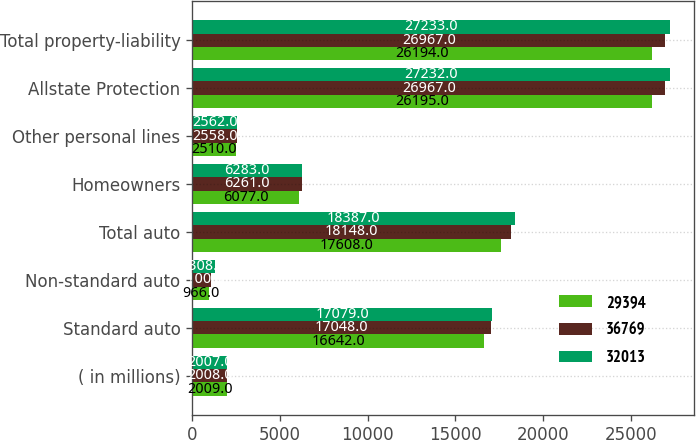Convert chart. <chart><loc_0><loc_0><loc_500><loc_500><stacked_bar_chart><ecel><fcel>( in millions)<fcel>Standard auto<fcel>Non-standard auto<fcel>Total auto<fcel>Homeowners<fcel>Other personal lines<fcel>Allstate Protection<fcel>Total property-liability<nl><fcel>29394<fcel>2009<fcel>16642<fcel>966<fcel>17608<fcel>6077<fcel>2510<fcel>26195<fcel>26194<nl><fcel>36769<fcel>2008<fcel>17048<fcel>1100<fcel>18148<fcel>6261<fcel>2558<fcel>26967<fcel>26967<nl><fcel>32013<fcel>2007<fcel>17079<fcel>1308<fcel>18387<fcel>6283<fcel>2562<fcel>27232<fcel>27233<nl></chart> 